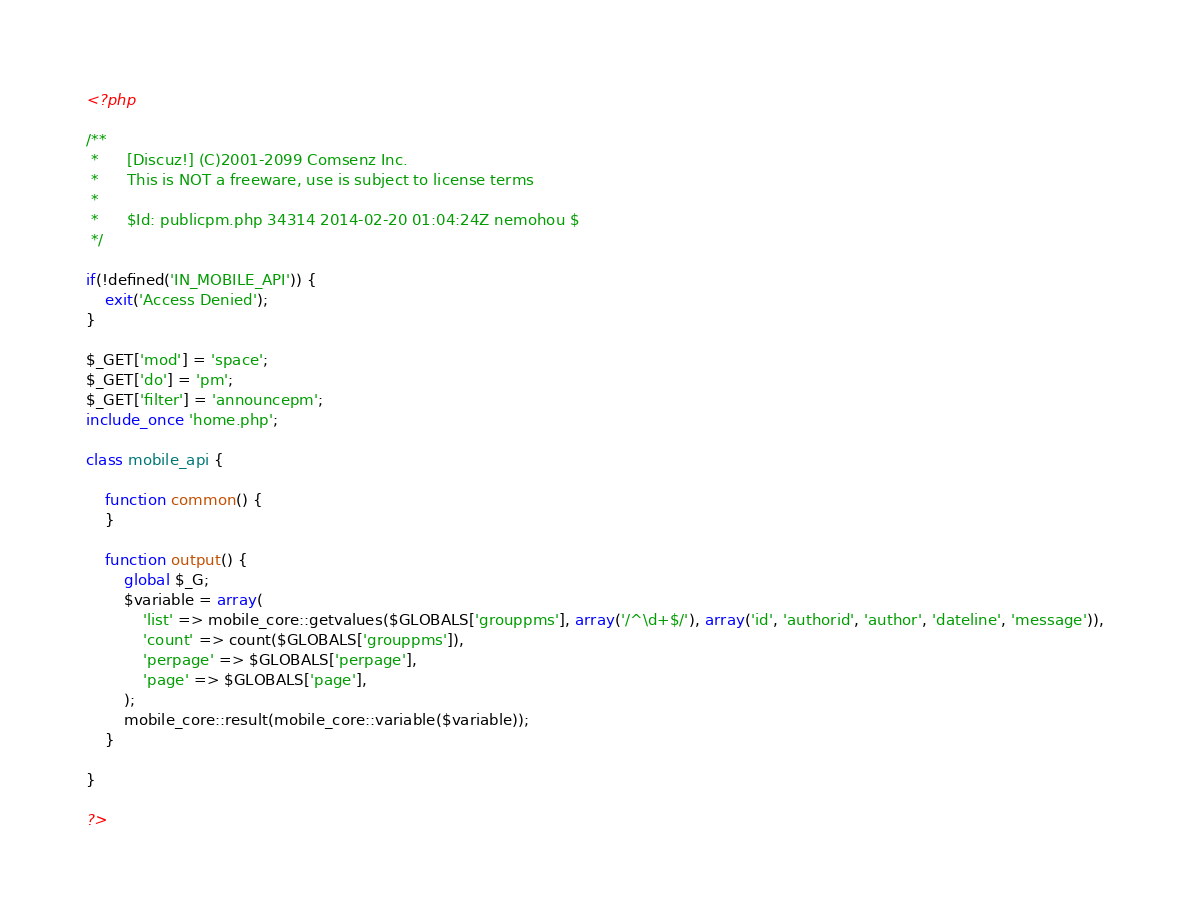<code> <loc_0><loc_0><loc_500><loc_500><_PHP_><?php

/**
 *      [Discuz!] (C)2001-2099 Comsenz Inc.
 *      This is NOT a freeware, use is subject to license terms
 *
 *      $Id: publicpm.php 34314 2014-02-20 01:04:24Z nemohou $
 */

if(!defined('IN_MOBILE_API')) {
	exit('Access Denied');
}

$_GET['mod'] = 'space';
$_GET['do'] = 'pm';
$_GET['filter'] = 'announcepm';
include_once 'home.php';

class mobile_api {

	function common() {
	}

	function output() {
		global $_G;
		$variable = array(
			'list' => mobile_core::getvalues($GLOBALS['grouppms'], array('/^\d+$/'), array('id', 'authorid', 'author', 'dateline', 'message')),
			'count' => count($GLOBALS['grouppms']),
			'perpage' => $GLOBALS['perpage'],
			'page' => $GLOBALS['page'],
		);
		mobile_core::result(mobile_core::variable($variable));
	}

}

?></code> 